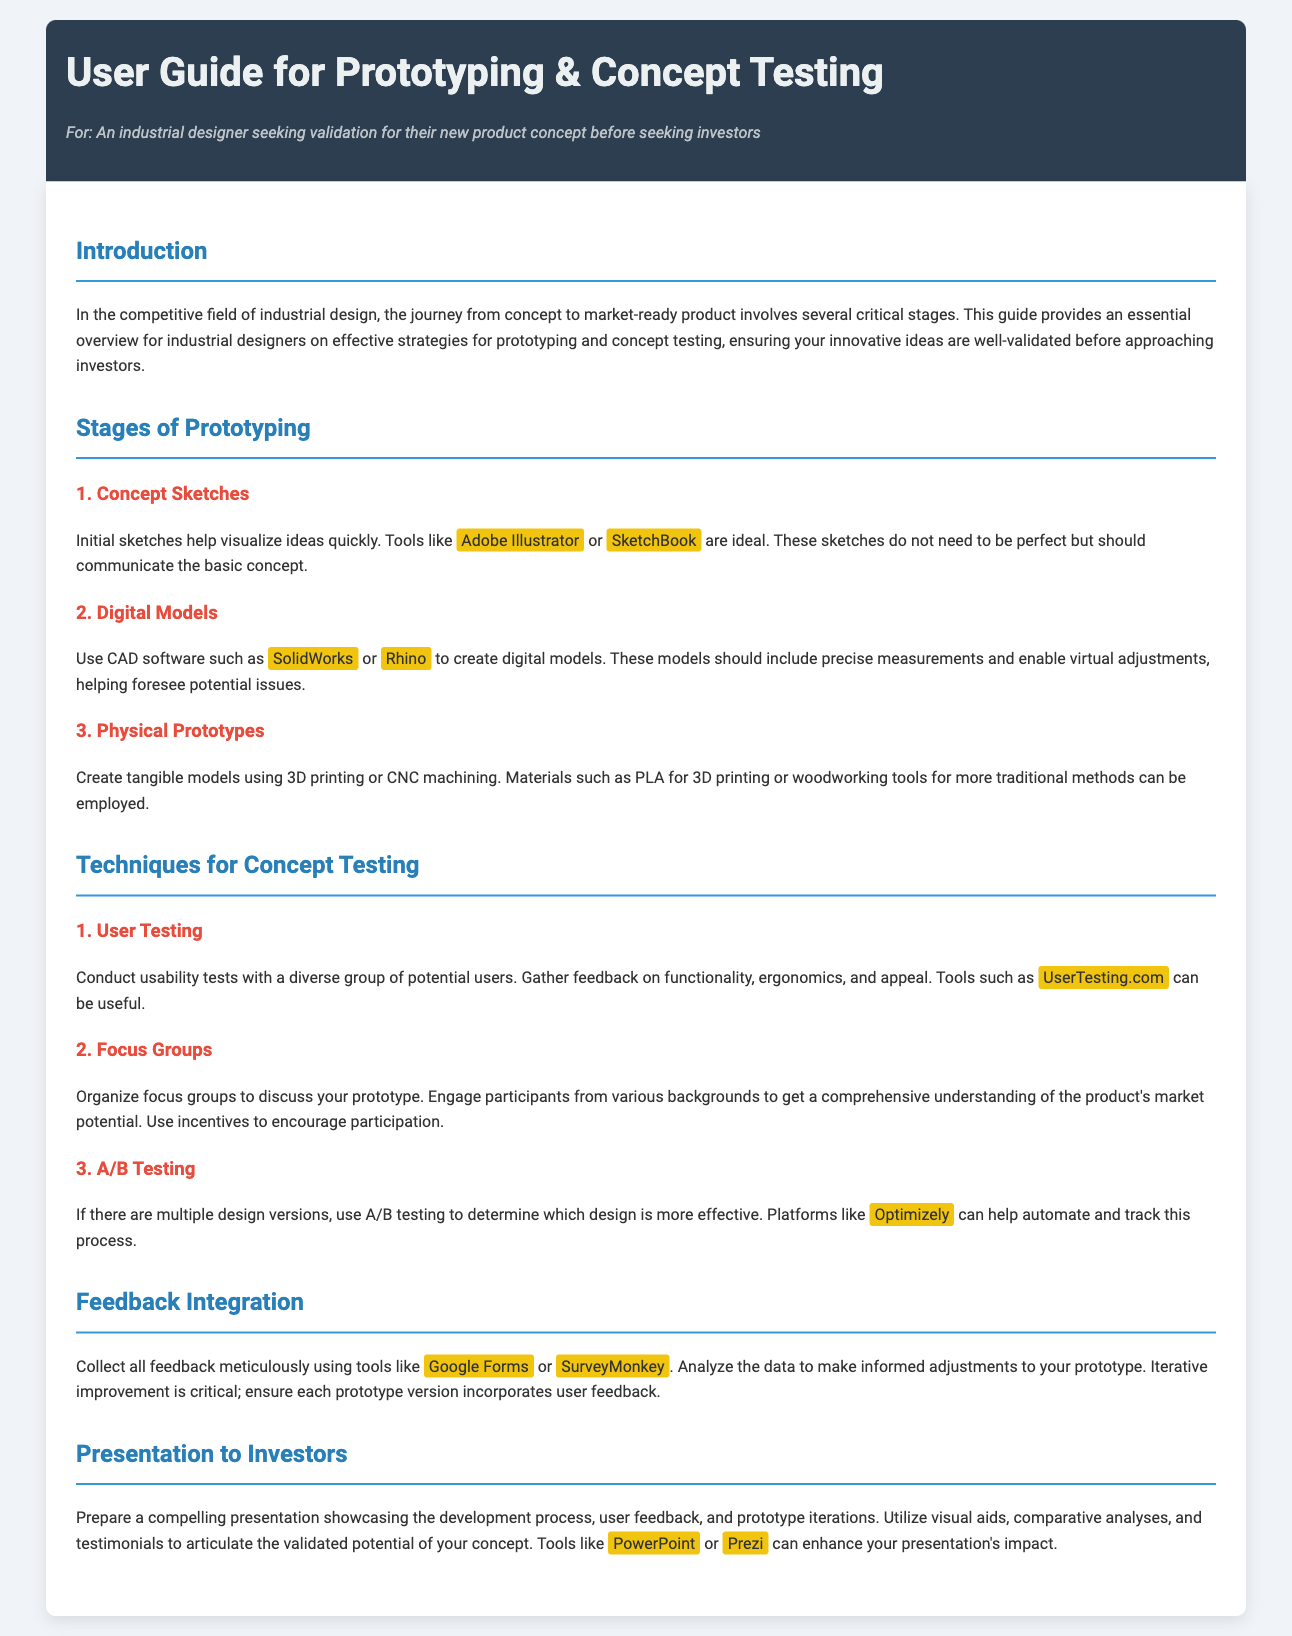what is the first stage of prototyping? The first stage of prototyping is identified in the "Stages of Prototyping" section of the document, which is "Concept Sketches."
Answer: Concept Sketches which software is suggested for creating digital models? The document suggests using CAD software for creating digital models, specifically mentioning "SolidWorks" or "Rhino."
Answer: SolidWorks or Rhino how many techniques for concept testing are mentioned in the guide? The guide lists three techniques for concept testing in the "Techniques for Concept Testing" section.
Answer: 3 what is the purpose of using focus groups in concept testing? The document describes focus groups as a method to discuss prototypes and gain understanding of market potential, indicating their role in gathering diverse opinions.
Answer: Understand market potential which tool can be used for collecting user feedback? The document lists specific tools for collecting user feedback in the "Feedback Integration" section, including "Google Forms" and "SurveyMonkey."
Answer: Google Forms or SurveyMonkey what is essential when preparing a presentation for investors? The guide emphasizes the need to showcase development process and user feedback in presentations to investors, highlighting the importance of clarity in communication.
Answer: Showcasing development process and user feedback 